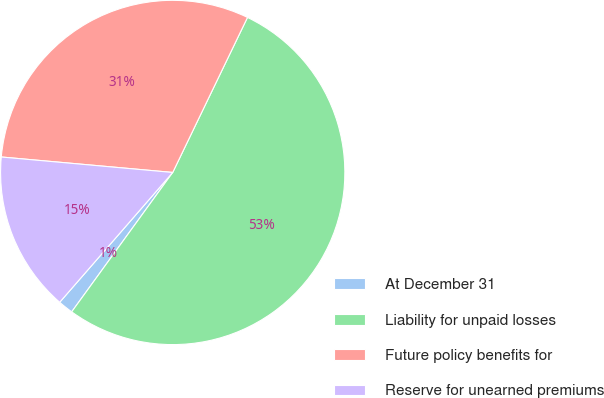Convert chart. <chart><loc_0><loc_0><loc_500><loc_500><pie_chart><fcel>At December 31<fcel>Liability for unpaid losses<fcel>Future policy benefits for<fcel>Reserve for unearned premiums<nl><fcel>1.42%<fcel>52.83%<fcel>30.72%<fcel>15.03%<nl></chart> 